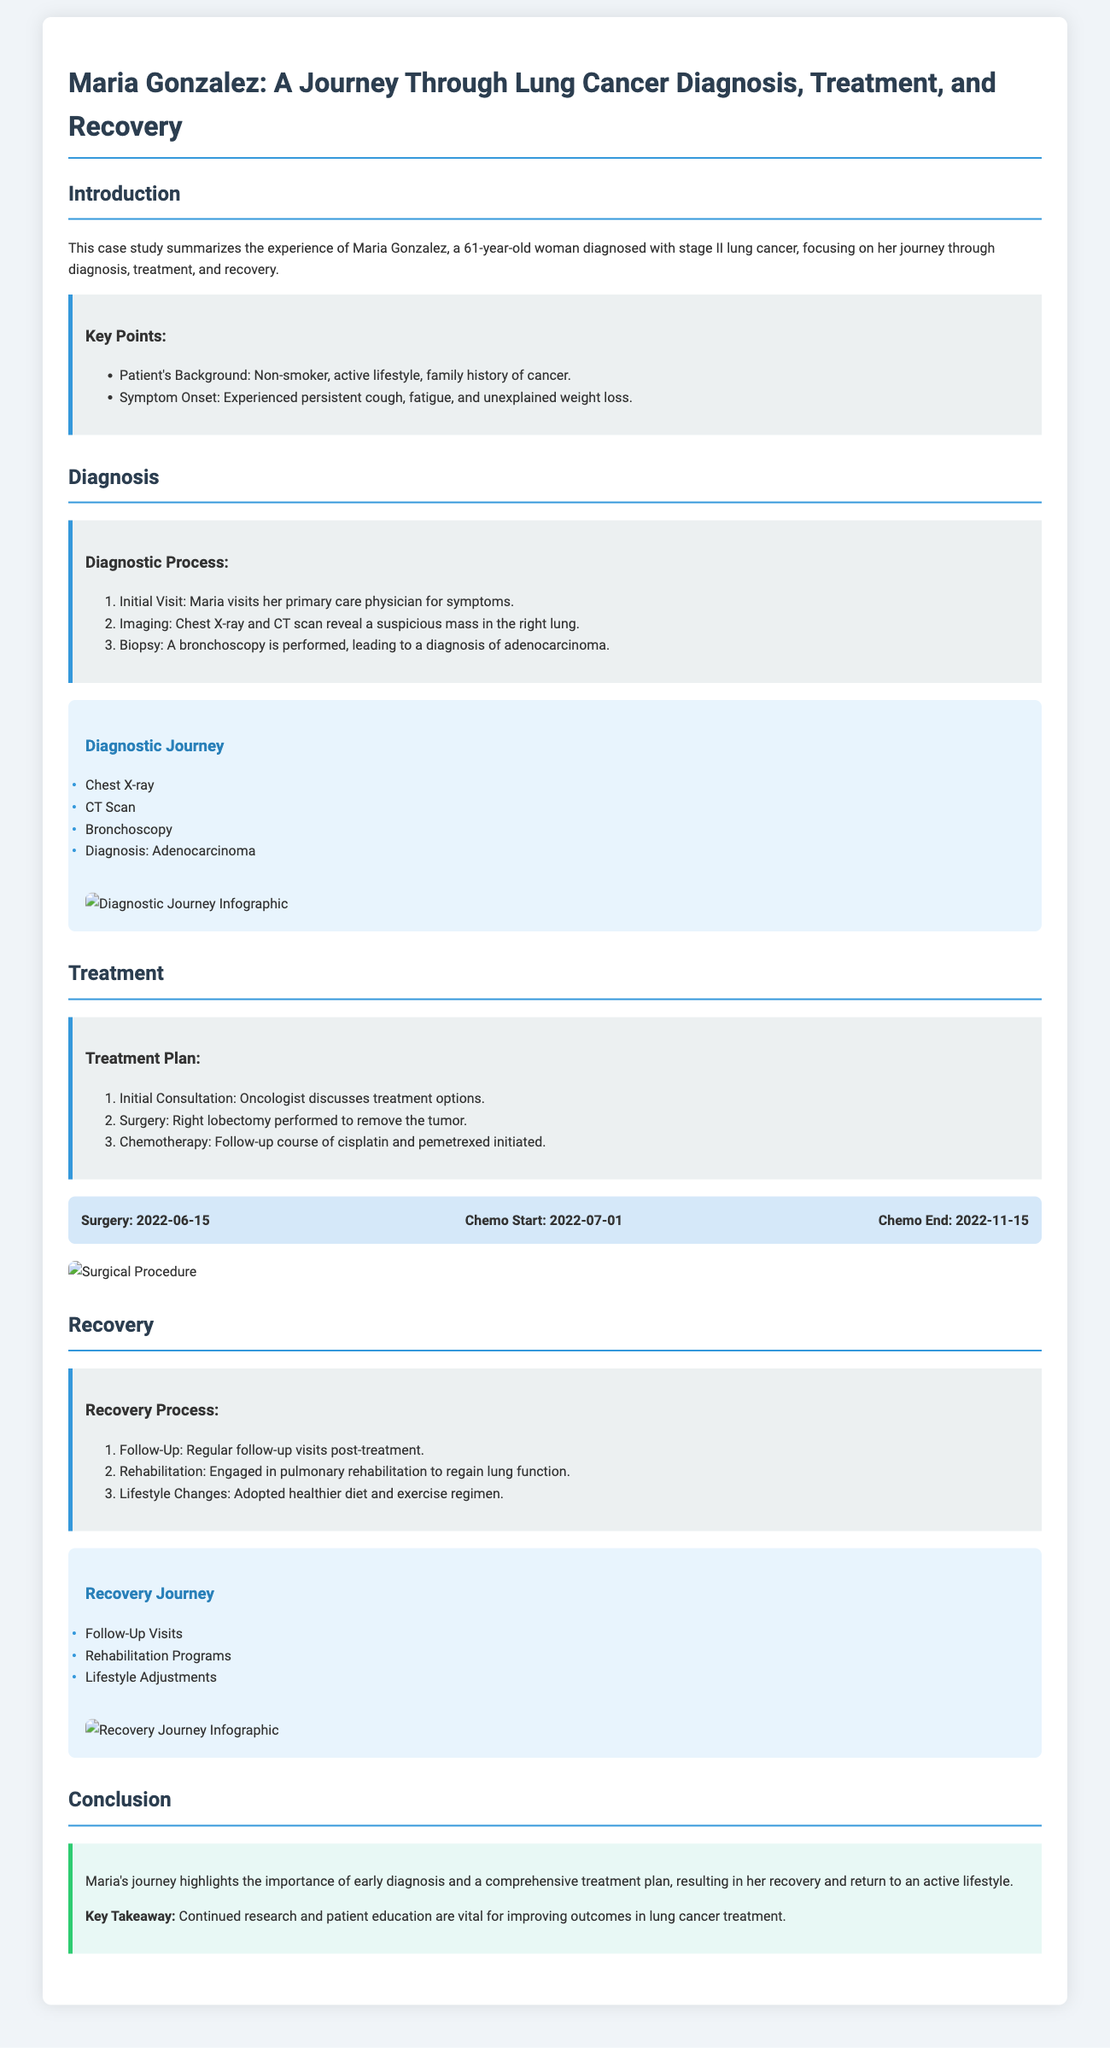What was Maria Gonzalez's age at diagnosis? The document states that Maria Gonzalez is a 61-year-old woman diagnosed with lung cancer.
Answer: 61 What type of cancer was diagnosed? The document specifies that Maria was diagnosed with adenocarcinoma.
Answer: Adenocarcinoma What symptom did Maria experience that indicated a health issue? Persistent cough, fatigue, and unexplained weight loss are mentioned as key symptoms experienced by Maria.
Answer: Persistent cough When did Maria's chemotherapy start? The document outlines that chemotherapy started on July 1, 2022.
Answer: July 1, 2022 What surgical procedure did Maria undergo? The text describes that Maria had a right lobectomy performed.
Answer: Right lobectomy How many steps are in the diagnostic process? The diagnostic process is composed of three steps as indicated in the document.
Answer: Three steps What is a key takeaway from Maria's journey? The conclusion highlights that continued research and patient education are vital for improving outcomes in lung cancer treatment.
Answer: Continued research and patient education What rehabilitation program did Maria engage in? The recovery section notes that Maria engaged in pulmonary rehabilitation.
Answer: Pulmonary rehabilitation What is the main focus of this case study? The case study focuses on Maria's journey through diagnosis, treatment, and recovery from lung cancer.
Answer: Diagnosis, treatment, and recovery 